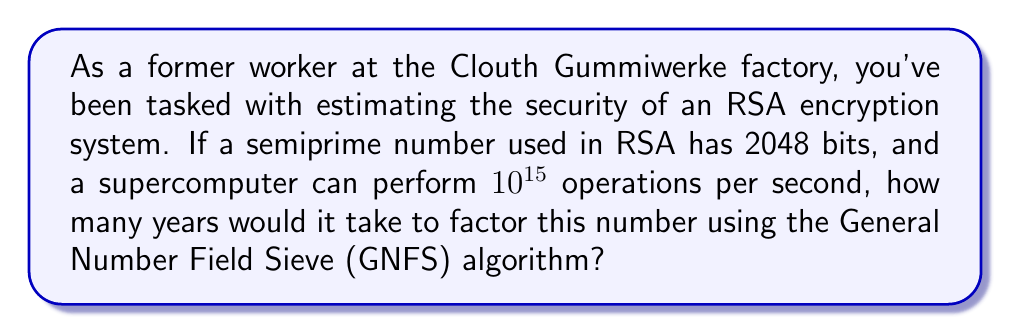Give your solution to this math problem. Let's approach this step-by-step:

1) The General Number Field Sieve (GNFS) algorithm is currently the most efficient known algorithm for factoring large semiprimes.

2) The complexity of GNFS for a number $n$ is approximately:

   $$O(e^{((64/9)^{1/3} + o(1))(\ln n)^{1/3}(\ln \ln n)^{2/3}})$$

3) For a 2048-bit number, $n \approx 2^{2048}$. Let's use this in our calculation:

   $$(\ln n)^{1/3}(\ln \ln n)^{2/3} \approx (\ln 2^{2048})^{1/3}(\ln \ln 2^{2048})^{2/3}$$
   $$\approx (2048 \ln 2)^{1/3}(\ln(2048 \ln 2))^{2/3}$$
   $$\approx 9.9$$

4) The number of operations required is approximately:

   $$e^{(64/9)^{1/3} \cdot 9.9} \approx 1.5 \times 10^{29}$$

5) Given a supercomputer that can perform $10^{15}$ operations per second:

   Time in seconds = $\frac{1.5 \times 10^{29}}{10^{15}} = 1.5 \times 10^{14}$ seconds

6) Convert to years:

   Years = $\frac{1.5 \times 10^{14}}{60 \times 60 \times 24 \times 365} \approx 4,755,443$ years
Answer: Approximately 4,755,443 years 